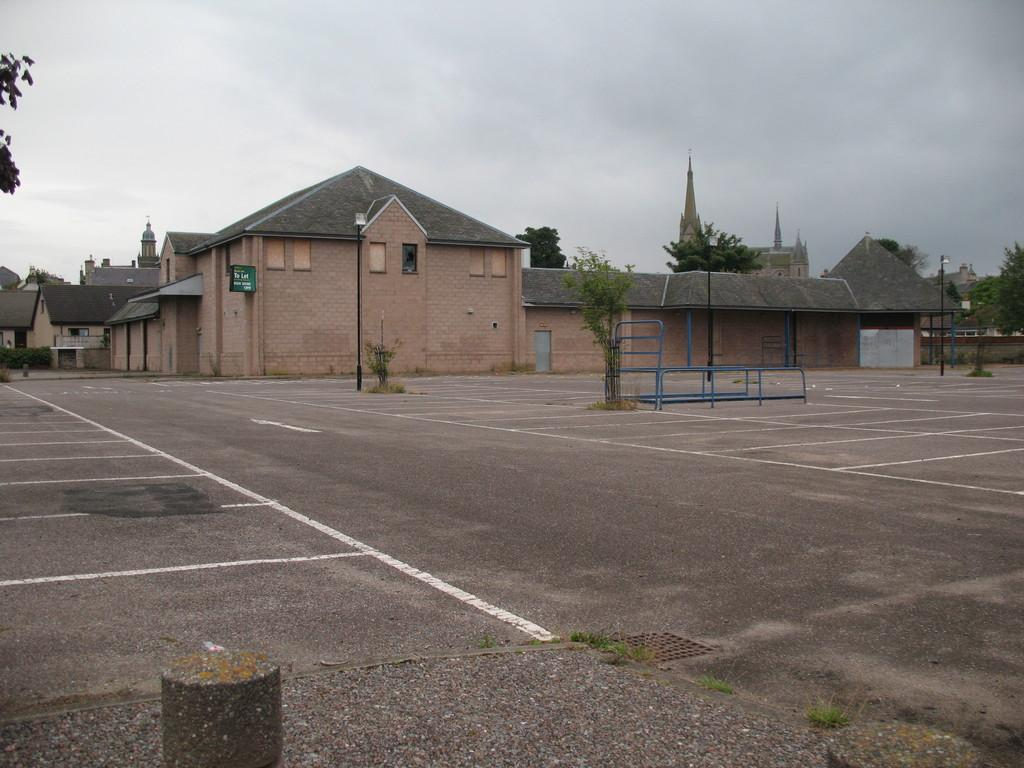What is the main feature of the image? There is a road in the image. What other elements can be seen alongside the road? Plants, poles, rods, and grass are visible in the image. What can be seen in the background of the image? Buildings, trees, a board, and the sky are visible in the background of the image. How many rabbits can be seen hopping on the grass in the image? There are no rabbits present in the image; it only features a road, plants, poles, rods, grass, buildings, trees, a board, and the sky. What type of celery is being used as a decoration on the board in the image? There is no celery present in the image; the board is not mentioned to have any decorations. 